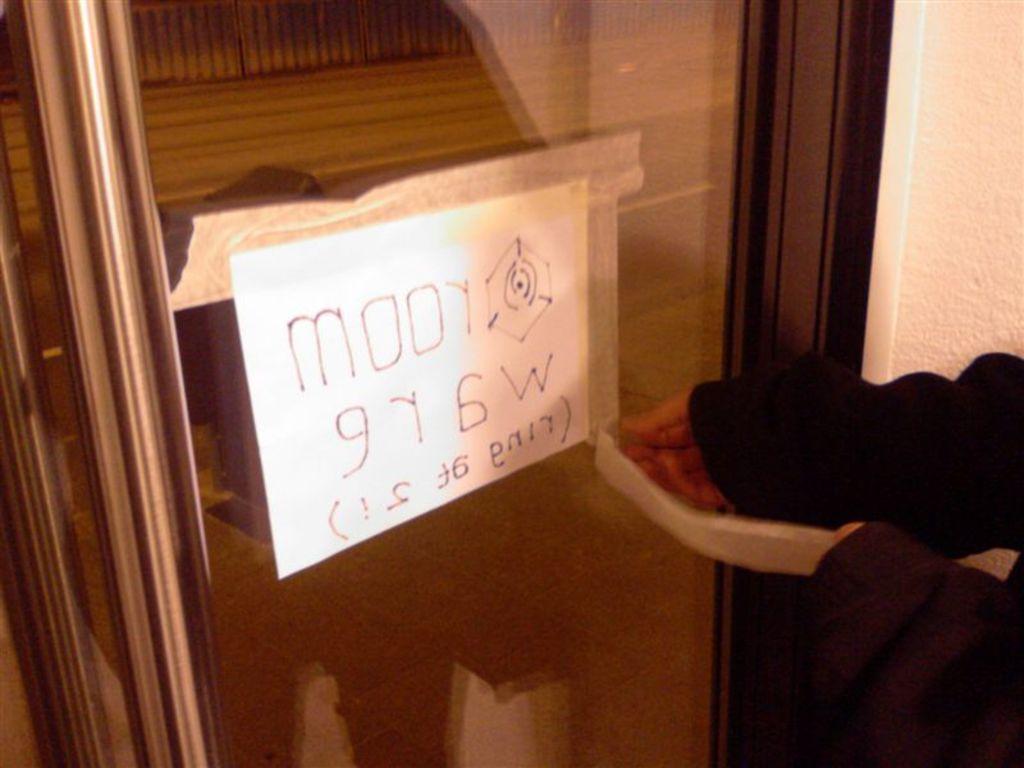Please provide a concise description of this image. In this picture we can see a paper on the door, and a person. 